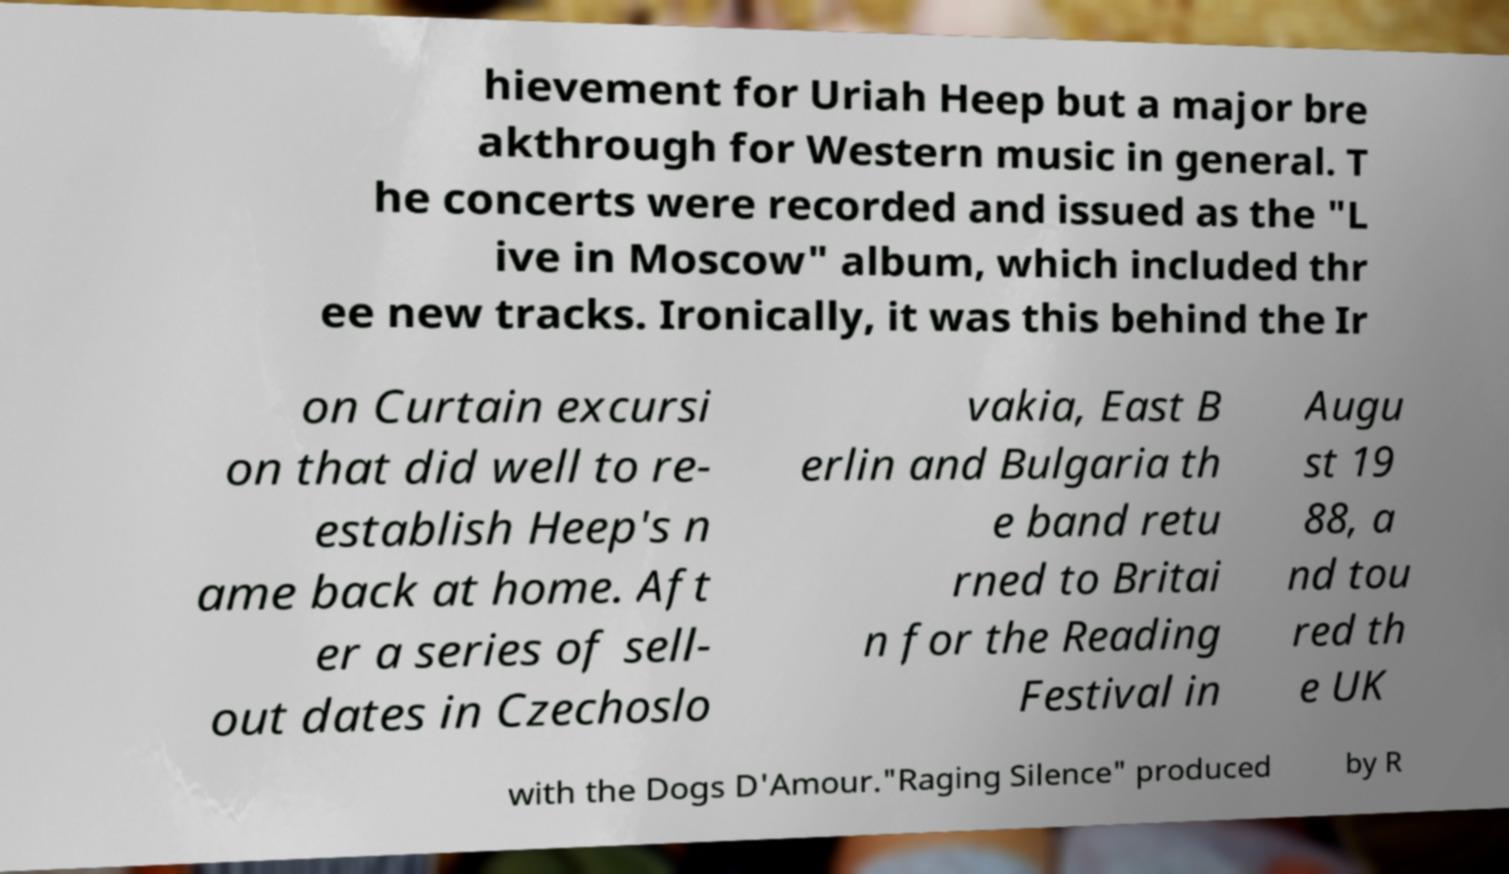For documentation purposes, I need the text within this image transcribed. Could you provide that? hievement for Uriah Heep but a major bre akthrough for Western music in general. T he concerts were recorded and issued as the "L ive in Moscow" album, which included thr ee new tracks. Ironically, it was this behind the Ir on Curtain excursi on that did well to re- establish Heep's n ame back at home. Aft er a series of sell- out dates in Czechoslo vakia, East B erlin and Bulgaria th e band retu rned to Britai n for the Reading Festival in Augu st 19 88, a nd tou red th e UK with the Dogs D'Amour."Raging Silence" produced by R 